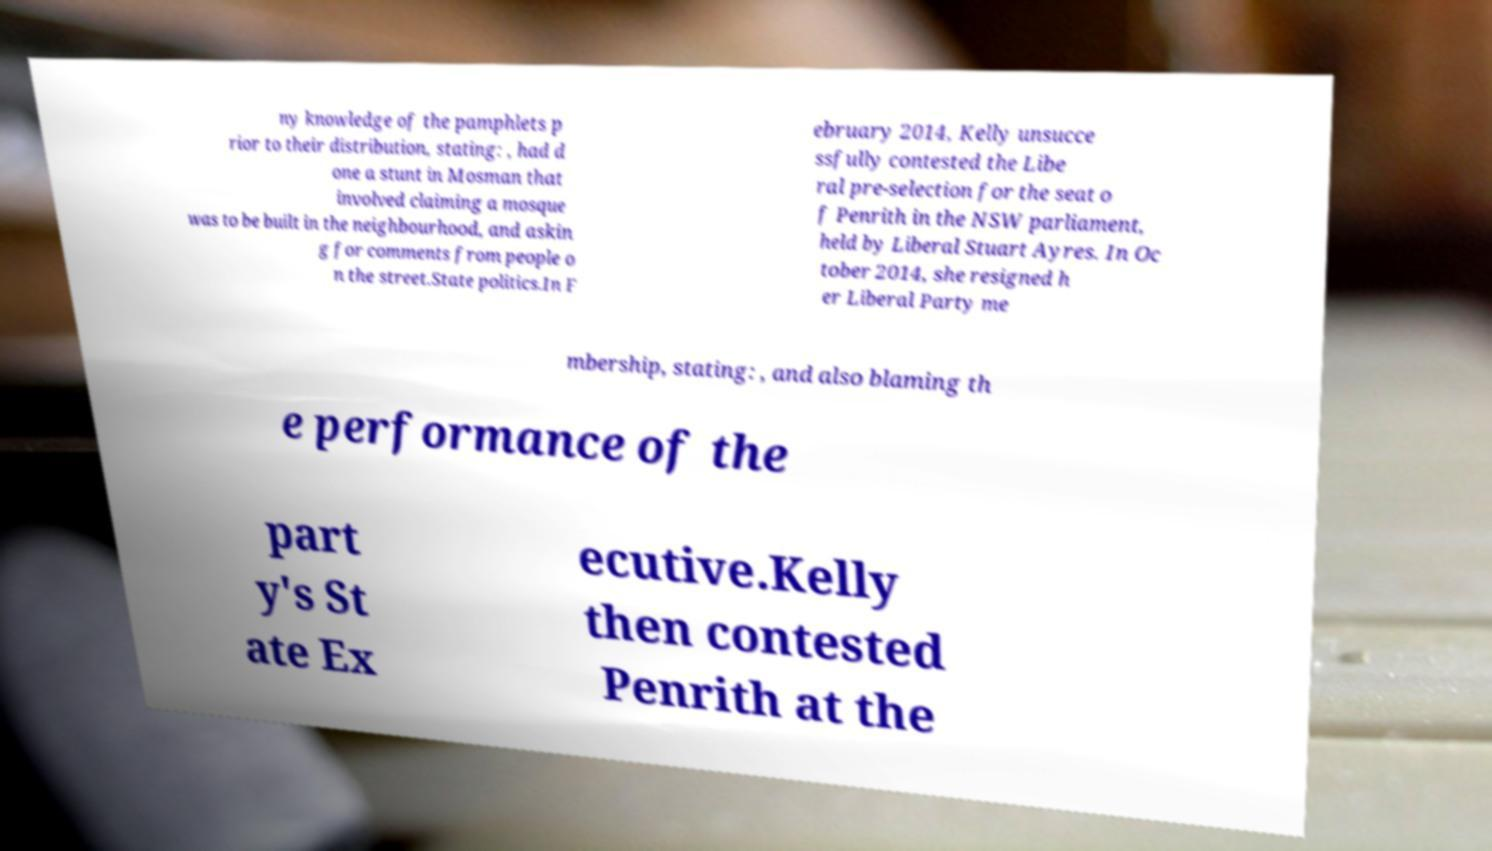Can you accurately transcribe the text from the provided image for me? ny knowledge of the pamphlets p rior to their distribution, stating: , had d one a stunt in Mosman that involved claiming a mosque was to be built in the neighbourhood, and askin g for comments from people o n the street.State politics.In F ebruary 2014, Kelly unsucce ssfully contested the Libe ral pre-selection for the seat o f Penrith in the NSW parliament, held by Liberal Stuart Ayres. In Oc tober 2014, she resigned h er Liberal Party me mbership, stating: , and also blaming th e performance of the part y's St ate Ex ecutive.Kelly then contested Penrith at the 